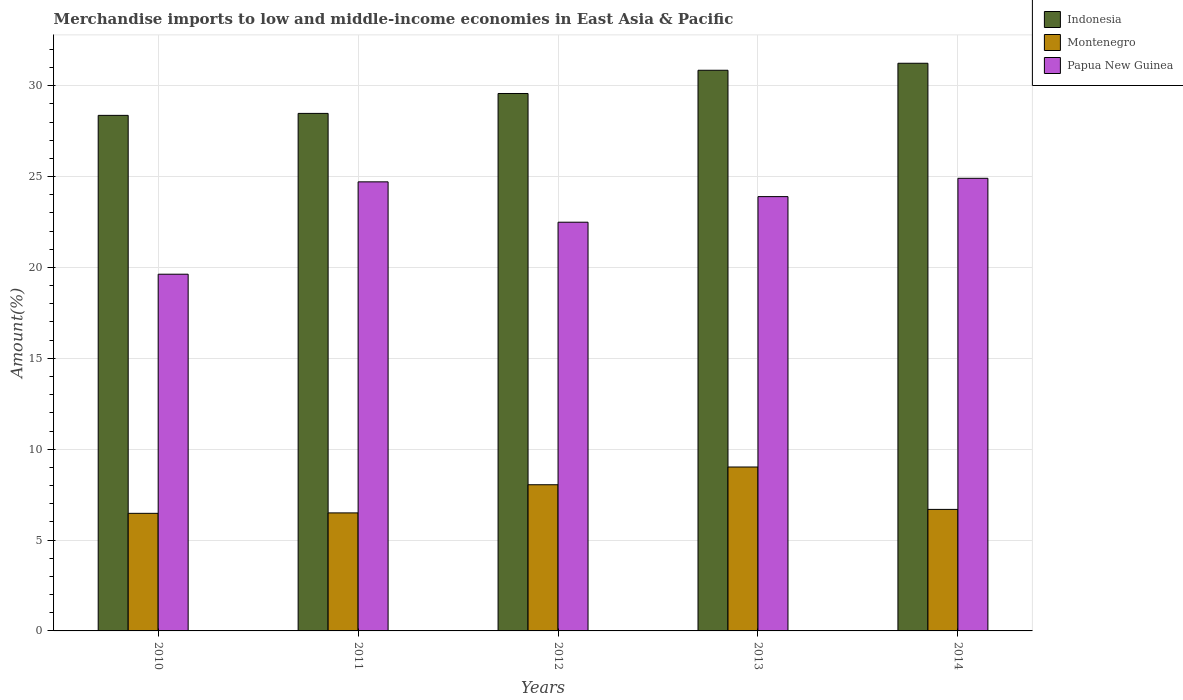How many different coloured bars are there?
Offer a very short reply. 3. How many groups of bars are there?
Your answer should be very brief. 5. Are the number of bars per tick equal to the number of legend labels?
Ensure brevity in your answer.  Yes. How many bars are there on the 3rd tick from the left?
Make the answer very short. 3. How many bars are there on the 1st tick from the right?
Make the answer very short. 3. What is the label of the 5th group of bars from the left?
Provide a short and direct response. 2014. In how many cases, is the number of bars for a given year not equal to the number of legend labels?
Ensure brevity in your answer.  0. What is the percentage of amount earned from merchandise imports in Papua New Guinea in 2012?
Your answer should be very brief. 22.49. Across all years, what is the maximum percentage of amount earned from merchandise imports in Indonesia?
Give a very brief answer. 31.24. Across all years, what is the minimum percentage of amount earned from merchandise imports in Indonesia?
Keep it short and to the point. 28.37. In which year was the percentage of amount earned from merchandise imports in Montenegro maximum?
Give a very brief answer. 2013. In which year was the percentage of amount earned from merchandise imports in Montenegro minimum?
Provide a short and direct response. 2010. What is the total percentage of amount earned from merchandise imports in Montenegro in the graph?
Provide a short and direct response. 36.72. What is the difference between the percentage of amount earned from merchandise imports in Indonesia in 2010 and that in 2013?
Your answer should be compact. -2.48. What is the difference between the percentage of amount earned from merchandise imports in Indonesia in 2010 and the percentage of amount earned from merchandise imports in Papua New Guinea in 2013?
Your response must be concise. 4.47. What is the average percentage of amount earned from merchandise imports in Indonesia per year?
Ensure brevity in your answer.  29.7. In the year 2013, what is the difference between the percentage of amount earned from merchandise imports in Indonesia and percentage of amount earned from merchandise imports in Montenegro?
Provide a succinct answer. 21.83. What is the ratio of the percentage of amount earned from merchandise imports in Montenegro in 2011 to that in 2014?
Make the answer very short. 0.97. Is the percentage of amount earned from merchandise imports in Indonesia in 2010 less than that in 2014?
Provide a succinct answer. Yes. Is the difference between the percentage of amount earned from merchandise imports in Indonesia in 2010 and 2014 greater than the difference between the percentage of amount earned from merchandise imports in Montenegro in 2010 and 2014?
Keep it short and to the point. No. What is the difference between the highest and the second highest percentage of amount earned from merchandise imports in Montenegro?
Provide a short and direct response. 0.98. What is the difference between the highest and the lowest percentage of amount earned from merchandise imports in Papua New Guinea?
Provide a short and direct response. 5.28. What does the 1st bar from the left in 2014 represents?
Your answer should be compact. Indonesia. What does the 1st bar from the right in 2011 represents?
Ensure brevity in your answer.  Papua New Guinea. Is it the case that in every year, the sum of the percentage of amount earned from merchandise imports in Indonesia and percentage of amount earned from merchandise imports in Montenegro is greater than the percentage of amount earned from merchandise imports in Papua New Guinea?
Ensure brevity in your answer.  Yes. How many bars are there?
Your response must be concise. 15. Are all the bars in the graph horizontal?
Give a very brief answer. No. What is the difference between two consecutive major ticks on the Y-axis?
Your answer should be compact. 5. Does the graph contain any zero values?
Provide a succinct answer. No. Where does the legend appear in the graph?
Give a very brief answer. Top right. How are the legend labels stacked?
Keep it short and to the point. Vertical. What is the title of the graph?
Ensure brevity in your answer.  Merchandise imports to low and middle-income economies in East Asia & Pacific. What is the label or title of the X-axis?
Your answer should be very brief. Years. What is the label or title of the Y-axis?
Offer a terse response. Amount(%). What is the Amount(%) of Indonesia in 2010?
Your answer should be compact. 28.37. What is the Amount(%) of Montenegro in 2010?
Provide a succinct answer. 6.47. What is the Amount(%) in Papua New Guinea in 2010?
Offer a terse response. 19.63. What is the Amount(%) in Indonesia in 2011?
Your response must be concise. 28.48. What is the Amount(%) in Montenegro in 2011?
Offer a terse response. 6.49. What is the Amount(%) in Papua New Guinea in 2011?
Your answer should be compact. 24.71. What is the Amount(%) in Indonesia in 2012?
Offer a terse response. 29.57. What is the Amount(%) of Montenegro in 2012?
Provide a short and direct response. 8.04. What is the Amount(%) of Papua New Guinea in 2012?
Provide a succinct answer. 22.49. What is the Amount(%) in Indonesia in 2013?
Offer a terse response. 30.85. What is the Amount(%) of Montenegro in 2013?
Give a very brief answer. 9.02. What is the Amount(%) in Papua New Guinea in 2013?
Provide a succinct answer. 23.9. What is the Amount(%) of Indonesia in 2014?
Ensure brevity in your answer.  31.24. What is the Amount(%) of Montenegro in 2014?
Offer a very short reply. 6.69. What is the Amount(%) in Papua New Guinea in 2014?
Offer a terse response. 24.91. Across all years, what is the maximum Amount(%) in Indonesia?
Your answer should be compact. 31.24. Across all years, what is the maximum Amount(%) in Montenegro?
Ensure brevity in your answer.  9.02. Across all years, what is the maximum Amount(%) in Papua New Guinea?
Keep it short and to the point. 24.91. Across all years, what is the minimum Amount(%) in Indonesia?
Make the answer very short. 28.37. Across all years, what is the minimum Amount(%) of Montenegro?
Your answer should be very brief. 6.47. Across all years, what is the minimum Amount(%) in Papua New Guinea?
Provide a succinct answer. 19.63. What is the total Amount(%) in Indonesia in the graph?
Make the answer very short. 148.51. What is the total Amount(%) in Montenegro in the graph?
Give a very brief answer. 36.72. What is the total Amount(%) of Papua New Guinea in the graph?
Provide a short and direct response. 115.64. What is the difference between the Amount(%) in Indonesia in 2010 and that in 2011?
Your response must be concise. -0.11. What is the difference between the Amount(%) in Montenegro in 2010 and that in 2011?
Provide a short and direct response. -0.02. What is the difference between the Amount(%) in Papua New Guinea in 2010 and that in 2011?
Make the answer very short. -5.08. What is the difference between the Amount(%) of Indonesia in 2010 and that in 2012?
Offer a very short reply. -1.2. What is the difference between the Amount(%) in Montenegro in 2010 and that in 2012?
Offer a very short reply. -1.57. What is the difference between the Amount(%) in Papua New Guinea in 2010 and that in 2012?
Your answer should be compact. -2.86. What is the difference between the Amount(%) of Indonesia in 2010 and that in 2013?
Offer a terse response. -2.48. What is the difference between the Amount(%) in Montenegro in 2010 and that in 2013?
Make the answer very short. -2.55. What is the difference between the Amount(%) in Papua New Guinea in 2010 and that in 2013?
Make the answer very short. -4.27. What is the difference between the Amount(%) in Indonesia in 2010 and that in 2014?
Your answer should be very brief. -2.87. What is the difference between the Amount(%) in Montenegro in 2010 and that in 2014?
Offer a terse response. -0.22. What is the difference between the Amount(%) of Papua New Guinea in 2010 and that in 2014?
Your answer should be compact. -5.28. What is the difference between the Amount(%) of Indonesia in 2011 and that in 2012?
Your response must be concise. -1.1. What is the difference between the Amount(%) of Montenegro in 2011 and that in 2012?
Provide a succinct answer. -1.55. What is the difference between the Amount(%) in Papua New Guinea in 2011 and that in 2012?
Your answer should be very brief. 2.22. What is the difference between the Amount(%) in Indonesia in 2011 and that in 2013?
Offer a very short reply. -2.37. What is the difference between the Amount(%) of Montenegro in 2011 and that in 2013?
Your answer should be very brief. -2.53. What is the difference between the Amount(%) in Papua New Guinea in 2011 and that in 2013?
Your answer should be compact. 0.81. What is the difference between the Amount(%) in Indonesia in 2011 and that in 2014?
Make the answer very short. -2.76. What is the difference between the Amount(%) of Montenegro in 2011 and that in 2014?
Keep it short and to the point. -0.19. What is the difference between the Amount(%) in Papua New Guinea in 2011 and that in 2014?
Keep it short and to the point. -0.2. What is the difference between the Amount(%) in Indonesia in 2012 and that in 2013?
Give a very brief answer. -1.28. What is the difference between the Amount(%) of Montenegro in 2012 and that in 2013?
Provide a short and direct response. -0.98. What is the difference between the Amount(%) in Papua New Guinea in 2012 and that in 2013?
Offer a very short reply. -1.41. What is the difference between the Amount(%) of Indonesia in 2012 and that in 2014?
Keep it short and to the point. -1.66. What is the difference between the Amount(%) in Montenegro in 2012 and that in 2014?
Offer a terse response. 1.36. What is the difference between the Amount(%) in Papua New Guinea in 2012 and that in 2014?
Offer a terse response. -2.42. What is the difference between the Amount(%) of Indonesia in 2013 and that in 2014?
Your answer should be compact. -0.39. What is the difference between the Amount(%) in Montenegro in 2013 and that in 2014?
Offer a terse response. 2.33. What is the difference between the Amount(%) of Papua New Guinea in 2013 and that in 2014?
Your answer should be compact. -1.01. What is the difference between the Amount(%) in Indonesia in 2010 and the Amount(%) in Montenegro in 2011?
Offer a very short reply. 21.88. What is the difference between the Amount(%) in Indonesia in 2010 and the Amount(%) in Papua New Guinea in 2011?
Your answer should be compact. 3.66. What is the difference between the Amount(%) in Montenegro in 2010 and the Amount(%) in Papua New Guinea in 2011?
Your answer should be very brief. -18.24. What is the difference between the Amount(%) of Indonesia in 2010 and the Amount(%) of Montenegro in 2012?
Offer a very short reply. 20.33. What is the difference between the Amount(%) of Indonesia in 2010 and the Amount(%) of Papua New Guinea in 2012?
Your answer should be compact. 5.88. What is the difference between the Amount(%) of Montenegro in 2010 and the Amount(%) of Papua New Guinea in 2012?
Your answer should be very brief. -16.02. What is the difference between the Amount(%) of Indonesia in 2010 and the Amount(%) of Montenegro in 2013?
Ensure brevity in your answer.  19.35. What is the difference between the Amount(%) in Indonesia in 2010 and the Amount(%) in Papua New Guinea in 2013?
Provide a succinct answer. 4.47. What is the difference between the Amount(%) in Montenegro in 2010 and the Amount(%) in Papua New Guinea in 2013?
Provide a short and direct response. -17.43. What is the difference between the Amount(%) in Indonesia in 2010 and the Amount(%) in Montenegro in 2014?
Your answer should be very brief. 21.68. What is the difference between the Amount(%) in Indonesia in 2010 and the Amount(%) in Papua New Guinea in 2014?
Your answer should be very brief. 3.46. What is the difference between the Amount(%) of Montenegro in 2010 and the Amount(%) of Papua New Guinea in 2014?
Offer a very short reply. -18.44. What is the difference between the Amount(%) of Indonesia in 2011 and the Amount(%) of Montenegro in 2012?
Give a very brief answer. 20.43. What is the difference between the Amount(%) of Indonesia in 2011 and the Amount(%) of Papua New Guinea in 2012?
Ensure brevity in your answer.  5.99. What is the difference between the Amount(%) of Montenegro in 2011 and the Amount(%) of Papua New Guinea in 2012?
Keep it short and to the point. -16. What is the difference between the Amount(%) of Indonesia in 2011 and the Amount(%) of Montenegro in 2013?
Your answer should be very brief. 19.46. What is the difference between the Amount(%) of Indonesia in 2011 and the Amount(%) of Papua New Guinea in 2013?
Your answer should be very brief. 4.58. What is the difference between the Amount(%) in Montenegro in 2011 and the Amount(%) in Papua New Guinea in 2013?
Keep it short and to the point. -17.41. What is the difference between the Amount(%) in Indonesia in 2011 and the Amount(%) in Montenegro in 2014?
Provide a succinct answer. 21.79. What is the difference between the Amount(%) of Indonesia in 2011 and the Amount(%) of Papua New Guinea in 2014?
Ensure brevity in your answer.  3.57. What is the difference between the Amount(%) of Montenegro in 2011 and the Amount(%) of Papua New Guinea in 2014?
Your answer should be very brief. -18.41. What is the difference between the Amount(%) of Indonesia in 2012 and the Amount(%) of Montenegro in 2013?
Offer a very short reply. 20.55. What is the difference between the Amount(%) of Indonesia in 2012 and the Amount(%) of Papua New Guinea in 2013?
Keep it short and to the point. 5.67. What is the difference between the Amount(%) in Montenegro in 2012 and the Amount(%) in Papua New Guinea in 2013?
Ensure brevity in your answer.  -15.86. What is the difference between the Amount(%) of Indonesia in 2012 and the Amount(%) of Montenegro in 2014?
Offer a terse response. 22.89. What is the difference between the Amount(%) in Indonesia in 2012 and the Amount(%) in Papua New Guinea in 2014?
Your response must be concise. 4.67. What is the difference between the Amount(%) of Montenegro in 2012 and the Amount(%) of Papua New Guinea in 2014?
Provide a short and direct response. -16.86. What is the difference between the Amount(%) of Indonesia in 2013 and the Amount(%) of Montenegro in 2014?
Provide a succinct answer. 24.17. What is the difference between the Amount(%) in Indonesia in 2013 and the Amount(%) in Papua New Guinea in 2014?
Give a very brief answer. 5.95. What is the difference between the Amount(%) in Montenegro in 2013 and the Amount(%) in Papua New Guinea in 2014?
Your answer should be compact. -15.89. What is the average Amount(%) of Indonesia per year?
Offer a terse response. 29.7. What is the average Amount(%) of Montenegro per year?
Your answer should be compact. 7.34. What is the average Amount(%) of Papua New Guinea per year?
Your answer should be very brief. 23.13. In the year 2010, what is the difference between the Amount(%) in Indonesia and Amount(%) in Montenegro?
Ensure brevity in your answer.  21.9. In the year 2010, what is the difference between the Amount(%) of Indonesia and Amount(%) of Papua New Guinea?
Give a very brief answer. 8.74. In the year 2010, what is the difference between the Amount(%) of Montenegro and Amount(%) of Papua New Guinea?
Make the answer very short. -13.16. In the year 2011, what is the difference between the Amount(%) in Indonesia and Amount(%) in Montenegro?
Ensure brevity in your answer.  21.98. In the year 2011, what is the difference between the Amount(%) of Indonesia and Amount(%) of Papua New Guinea?
Your answer should be very brief. 3.77. In the year 2011, what is the difference between the Amount(%) in Montenegro and Amount(%) in Papua New Guinea?
Your response must be concise. -18.22. In the year 2012, what is the difference between the Amount(%) in Indonesia and Amount(%) in Montenegro?
Provide a succinct answer. 21.53. In the year 2012, what is the difference between the Amount(%) in Indonesia and Amount(%) in Papua New Guinea?
Your answer should be compact. 7.08. In the year 2012, what is the difference between the Amount(%) in Montenegro and Amount(%) in Papua New Guinea?
Your answer should be compact. -14.45. In the year 2013, what is the difference between the Amount(%) of Indonesia and Amount(%) of Montenegro?
Your answer should be compact. 21.83. In the year 2013, what is the difference between the Amount(%) in Indonesia and Amount(%) in Papua New Guinea?
Keep it short and to the point. 6.95. In the year 2013, what is the difference between the Amount(%) of Montenegro and Amount(%) of Papua New Guinea?
Give a very brief answer. -14.88. In the year 2014, what is the difference between the Amount(%) of Indonesia and Amount(%) of Montenegro?
Offer a terse response. 24.55. In the year 2014, what is the difference between the Amount(%) in Indonesia and Amount(%) in Papua New Guinea?
Provide a short and direct response. 6.33. In the year 2014, what is the difference between the Amount(%) of Montenegro and Amount(%) of Papua New Guinea?
Your answer should be very brief. -18.22. What is the ratio of the Amount(%) in Papua New Guinea in 2010 to that in 2011?
Your response must be concise. 0.79. What is the ratio of the Amount(%) of Indonesia in 2010 to that in 2012?
Give a very brief answer. 0.96. What is the ratio of the Amount(%) of Montenegro in 2010 to that in 2012?
Offer a very short reply. 0.8. What is the ratio of the Amount(%) in Papua New Guinea in 2010 to that in 2012?
Offer a very short reply. 0.87. What is the ratio of the Amount(%) of Indonesia in 2010 to that in 2013?
Provide a short and direct response. 0.92. What is the ratio of the Amount(%) in Montenegro in 2010 to that in 2013?
Your answer should be very brief. 0.72. What is the ratio of the Amount(%) in Papua New Guinea in 2010 to that in 2013?
Ensure brevity in your answer.  0.82. What is the ratio of the Amount(%) of Indonesia in 2010 to that in 2014?
Your response must be concise. 0.91. What is the ratio of the Amount(%) of Montenegro in 2010 to that in 2014?
Your response must be concise. 0.97. What is the ratio of the Amount(%) in Papua New Guinea in 2010 to that in 2014?
Your answer should be very brief. 0.79. What is the ratio of the Amount(%) in Indonesia in 2011 to that in 2012?
Ensure brevity in your answer.  0.96. What is the ratio of the Amount(%) in Montenegro in 2011 to that in 2012?
Ensure brevity in your answer.  0.81. What is the ratio of the Amount(%) of Papua New Guinea in 2011 to that in 2012?
Provide a succinct answer. 1.1. What is the ratio of the Amount(%) in Montenegro in 2011 to that in 2013?
Give a very brief answer. 0.72. What is the ratio of the Amount(%) in Papua New Guinea in 2011 to that in 2013?
Offer a terse response. 1.03. What is the ratio of the Amount(%) of Indonesia in 2011 to that in 2014?
Offer a very short reply. 0.91. What is the ratio of the Amount(%) in Montenegro in 2011 to that in 2014?
Your answer should be compact. 0.97. What is the ratio of the Amount(%) of Papua New Guinea in 2011 to that in 2014?
Your answer should be very brief. 0.99. What is the ratio of the Amount(%) in Indonesia in 2012 to that in 2013?
Ensure brevity in your answer.  0.96. What is the ratio of the Amount(%) in Montenegro in 2012 to that in 2013?
Offer a terse response. 0.89. What is the ratio of the Amount(%) in Papua New Guinea in 2012 to that in 2013?
Your response must be concise. 0.94. What is the ratio of the Amount(%) of Indonesia in 2012 to that in 2014?
Offer a terse response. 0.95. What is the ratio of the Amount(%) in Montenegro in 2012 to that in 2014?
Provide a short and direct response. 1.2. What is the ratio of the Amount(%) of Papua New Guinea in 2012 to that in 2014?
Provide a succinct answer. 0.9. What is the ratio of the Amount(%) in Montenegro in 2013 to that in 2014?
Keep it short and to the point. 1.35. What is the ratio of the Amount(%) of Papua New Guinea in 2013 to that in 2014?
Ensure brevity in your answer.  0.96. What is the difference between the highest and the second highest Amount(%) in Indonesia?
Ensure brevity in your answer.  0.39. What is the difference between the highest and the second highest Amount(%) in Montenegro?
Offer a very short reply. 0.98. What is the difference between the highest and the second highest Amount(%) of Papua New Guinea?
Offer a terse response. 0.2. What is the difference between the highest and the lowest Amount(%) in Indonesia?
Offer a very short reply. 2.87. What is the difference between the highest and the lowest Amount(%) of Montenegro?
Ensure brevity in your answer.  2.55. What is the difference between the highest and the lowest Amount(%) of Papua New Guinea?
Ensure brevity in your answer.  5.28. 